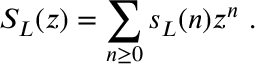Convert formula to latex. <formula><loc_0><loc_0><loc_500><loc_500>S _ { L } ( z ) = \sum _ { n \geq 0 } s _ { L } ( n ) z ^ { n } \ .</formula> 